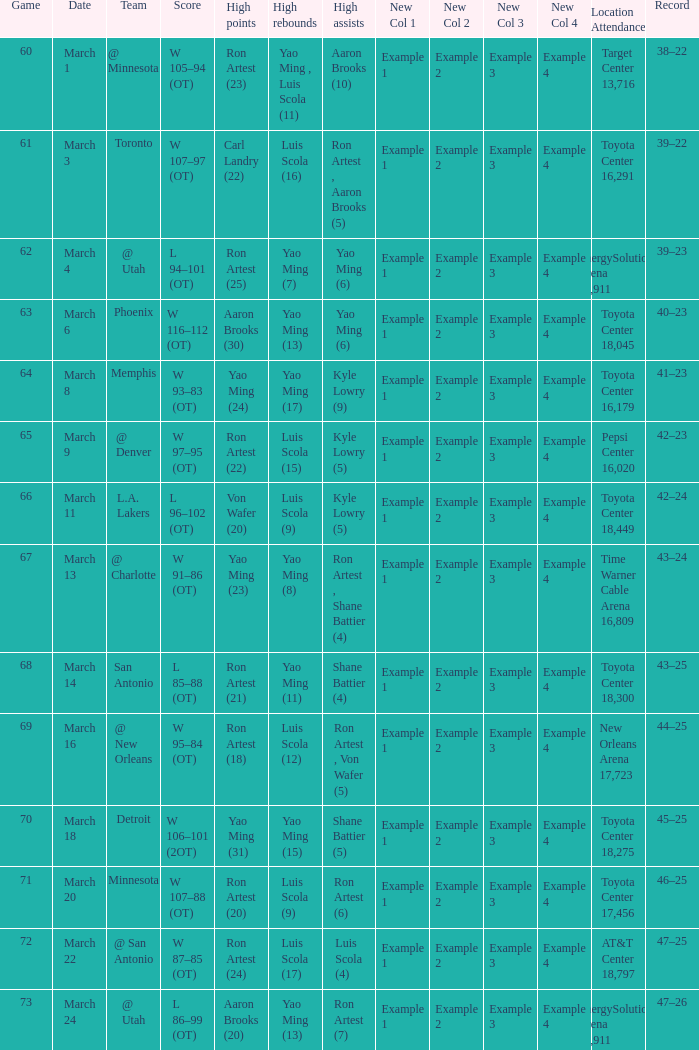Who had the most poinst in game 72? Ron Artest (24). 